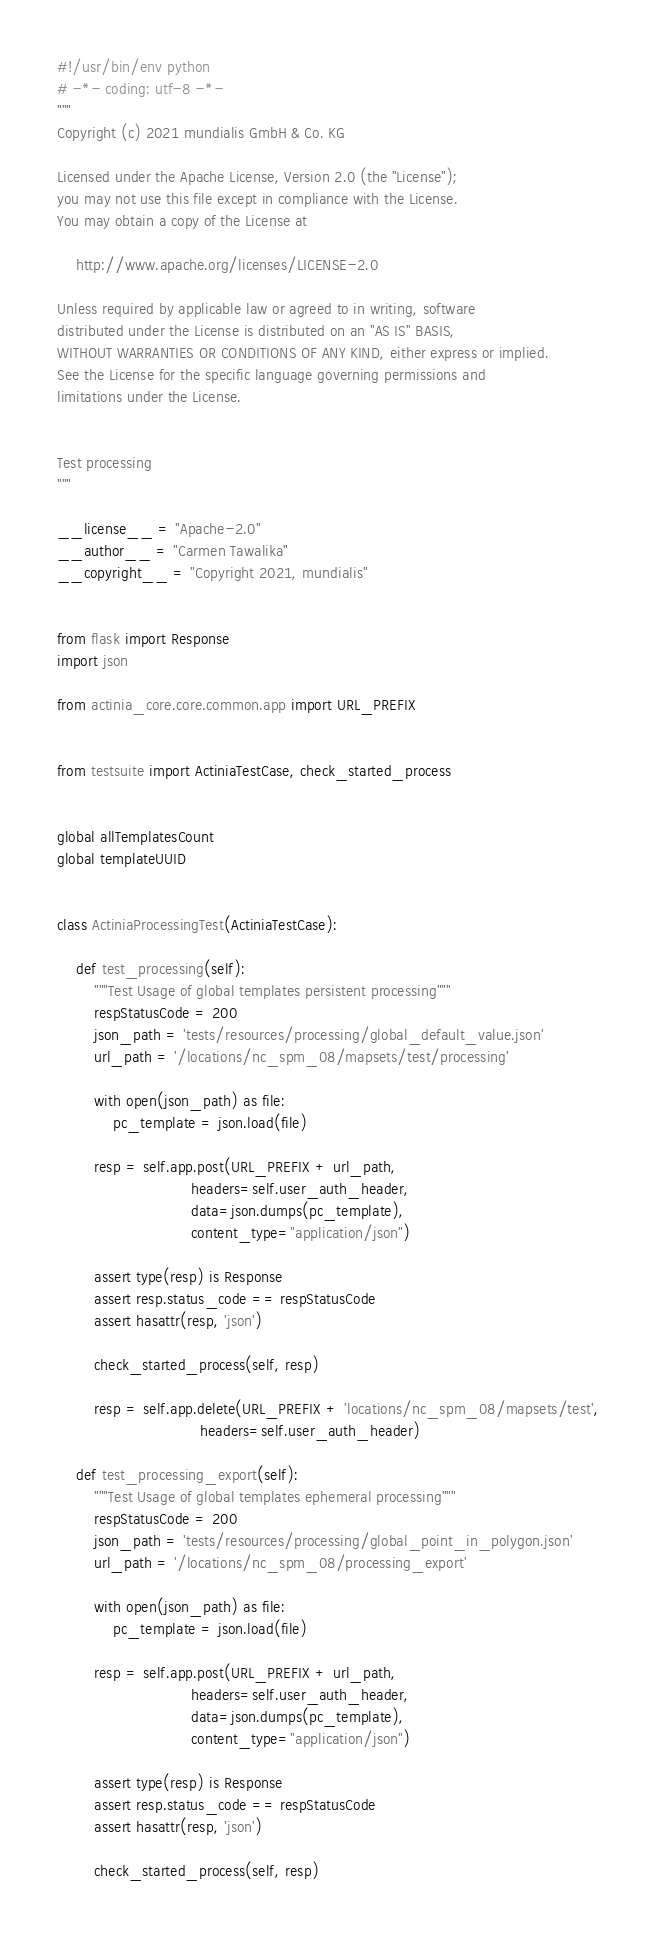<code> <loc_0><loc_0><loc_500><loc_500><_Python_>#!/usr/bin/env python
# -*- coding: utf-8 -*-
"""
Copyright (c) 2021 mundialis GmbH & Co. KG

Licensed under the Apache License, Version 2.0 (the "License");
you may not use this file except in compliance with the License.
You may obtain a copy of the License at

    http://www.apache.org/licenses/LICENSE-2.0

Unless required by applicable law or agreed to in writing, software
distributed under the License is distributed on an "AS IS" BASIS,
WITHOUT WARRANTIES OR CONDITIONS OF ANY KIND, either express or implied.
See the License for the specific language governing permissions and
limitations under the License.


Test processing
"""

__license__ = "Apache-2.0"
__author__ = "Carmen Tawalika"
__copyright__ = "Copyright 2021, mundialis"


from flask import Response
import json

from actinia_core.core.common.app import URL_PREFIX


from testsuite import ActiniaTestCase, check_started_process


global allTemplatesCount
global templateUUID


class ActiniaProcessingTest(ActiniaTestCase):

    def test_processing(self):
        """Test Usage of global templates persistent processing"""
        respStatusCode = 200
        json_path = 'tests/resources/processing/global_default_value.json'
        url_path = '/locations/nc_spm_08/mapsets/test/processing'

        with open(json_path) as file:
            pc_template = json.load(file)

        resp = self.app.post(URL_PREFIX + url_path,
                             headers=self.user_auth_header,
                             data=json.dumps(pc_template),
                             content_type="application/json")

        assert type(resp) is Response
        assert resp.status_code == respStatusCode
        assert hasattr(resp, 'json')

        check_started_process(self, resp)

        resp = self.app.delete(URL_PREFIX + 'locations/nc_spm_08/mapsets/test',
                               headers=self.user_auth_header)

    def test_processing_export(self):
        """Test Usage of global templates ephemeral processing"""
        respStatusCode = 200
        json_path = 'tests/resources/processing/global_point_in_polygon.json'
        url_path = '/locations/nc_spm_08/processing_export'

        with open(json_path) as file:
            pc_template = json.load(file)

        resp = self.app.post(URL_PREFIX + url_path,
                             headers=self.user_auth_header,
                             data=json.dumps(pc_template),
                             content_type="application/json")

        assert type(resp) is Response
        assert resp.status_code == respStatusCode
        assert hasattr(resp, 'json')

        check_started_process(self, resp)
</code> 